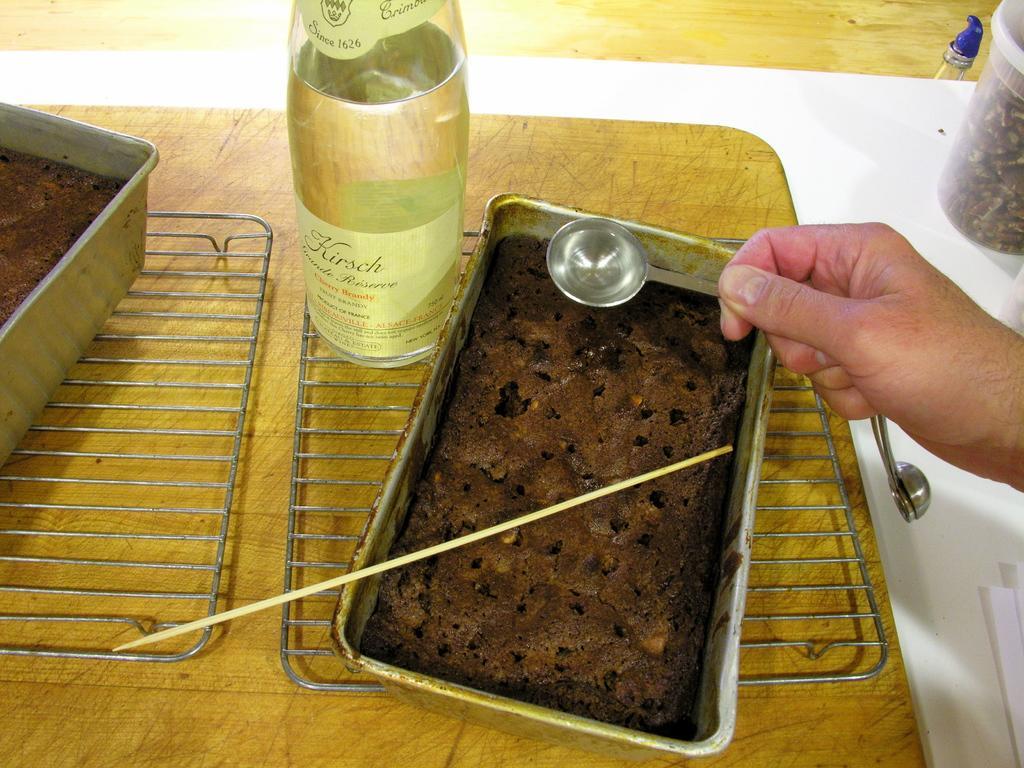Please provide a concise description of this image. In this picture I can see there is some food kept in a container and there is a man holding a spoon. There is a jar here. 